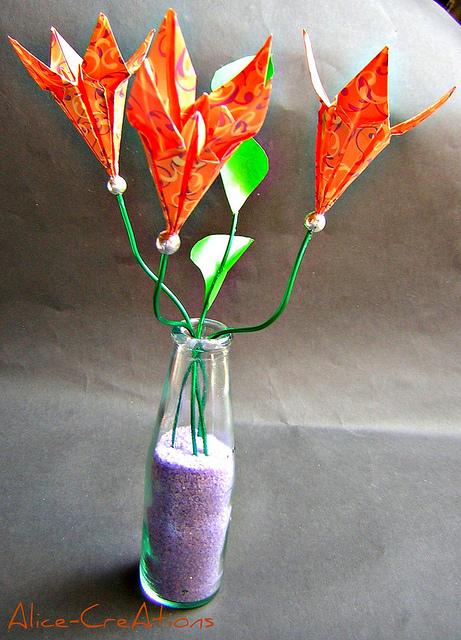What is in the vase?
Concise answer only. Paper flowers. What is inside the jar?
Give a very brief answer. Sand. Is the jar clear?
Give a very brief answer. Yes. Are these real flowers?
Write a very short answer. No. 